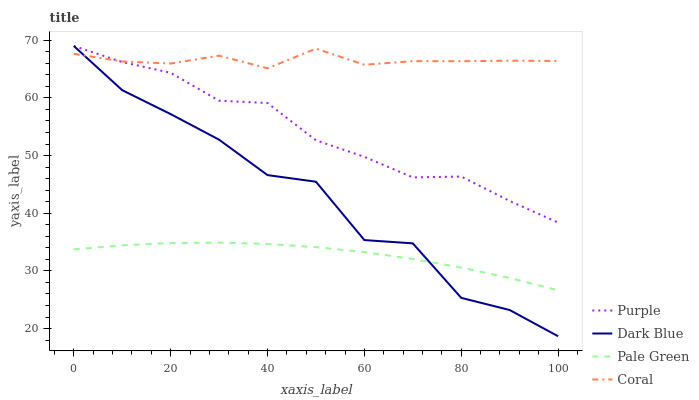Does Pale Green have the minimum area under the curve?
Answer yes or no. Yes. Does Coral have the maximum area under the curve?
Answer yes or no. Yes. Does Dark Blue have the minimum area under the curve?
Answer yes or no. No. Does Dark Blue have the maximum area under the curve?
Answer yes or no. No. Is Pale Green the smoothest?
Answer yes or no. Yes. Is Dark Blue the roughest?
Answer yes or no. Yes. Is Coral the smoothest?
Answer yes or no. No. Is Coral the roughest?
Answer yes or no. No. Does Dark Blue have the lowest value?
Answer yes or no. Yes. Does Coral have the lowest value?
Answer yes or no. No. Does Dark Blue have the highest value?
Answer yes or no. Yes. Does Coral have the highest value?
Answer yes or no. No. Is Pale Green less than Coral?
Answer yes or no. Yes. Is Purple greater than Pale Green?
Answer yes or no. Yes. Does Dark Blue intersect Pale Green?
Answer yes or no. Yes. Is Dark Blue less than Pale Green?
Answer yes or no. No. Is Dark Blue greater than Pale Green?
Answer yes or no. No. Does Pale Green intersect Coral?
Answer yes or no. No. 